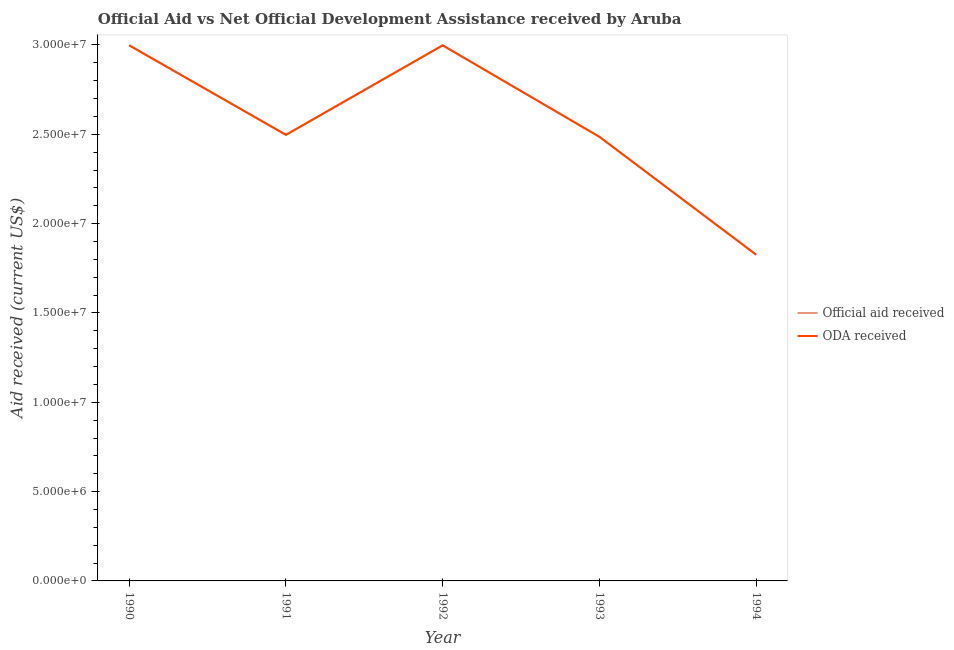What is the oda received in 1993?
Your response must be concise. 2.49e+07. Across all years, what is the maximum oda received?
Offer a very short reply. 3.00e+07. Across all years, what is the minimum official aid received?
Ensure brevity in your answer.  1.83e+07. In which year was the oda received maximum?
Provide a succinct answer. 1990. What is the total official aid received in the graph?
Your response must be concise. 1.28e+08. What is the difference between the oda received in 1991 and that in 1994?
Ensure brevity in your answer.  6.71e+06. What is the difference between the official aid received in 1991 and the oda received in 1993?
Offer a terse response. 1.10e+05. What is the average oda received per year?
Offer a terse response. 2.56e+07. In the year 1993, what is the difference between the official aid received and oda received?
Offer a terse response. 0. What is the ratio of the oda received in 1990 to that in 1991?
Provide a succinct answer. 1.2. Is the oda received in 1991 less than that in 1994?
Your response must be concise. No. Is the difference between the oda received in 1991 and 1992 greater than the difference between the official aid received in 1991 and 1992?
Your response must be concise. No. What is the difference between the highest and the second highest oda received?
Offer a terse response. 0. What is the difference between the highest and the lowest oda received?
Your answer should be compact. 1.17e+07. In how many years, is the oda received greater than the average oda received taken over all years?
Your answer should be very brief. 2. Is the sum of the official aid received in 1991 and 1993 greater than the maximum oda received across all years?
Your response must be concise. Yes. Does the oda received monotonically increase over the years?
Your answer should be compact. No. How many lines are there?
Give a very brief answer. 2. Does the graph contain grids?
Keep it short and to the point. No. Where does the legend appear in the graph?
Your answer should be very brief. Center right. How are the legend labels stacked?
Your answer should be very brief. Vertical. What is the title of the graph?
Make the answer very short. Official Aid vs Net Official Development Assistance received by Aruba . Does "Birth rate" appear as one of the legend labels in the graph?
Provide a short and direct response. No. What is the label or title of the X-axis?
Offer a very short reply. Year. What is the label or title of the Y-axis?
Provide a short and direct response. Aid received (current US$). What is the Aid received (current US$) in Official aid received in 1990?
Ensure brevity in your answer.  3.00e+07. What is the Aid received (current US$) in ODA received in 1990?
Your response must be concise. 3.00e+07. What is the Aid received (current US$) in Official aid received in 1991?
Offer a very short reply. 2.50e+07. What is the Aid received (current US$) of ODA received in 1991?
Ensure brevity in your answer.  2.50e+07. What is the Aid received (current US$) in Official aid received in 1992?
Provide a succinct answer. 3.00e+07. What is the Aid received (current US$) of ODA received in 1992?
Your answer should be very brief. 3.00e+07. What is the Aid received (current US$) of Official aid received in 1993?
Provide a succinct answer. 2.49e+07. What is the Aid received (current US$) in ODA received in 1993?
Offer a terse response. 2.49e+07. What is the Aid received (current US$) in Official aid received in 1994?
Offer a very short reply. 1.83e+07. What is the Aid received (current US$) of ODA received in 1994?
Offer a terse response. 1.83e+07. Across all years, what is the maximum Aid received (current US$) in Official aid received?
Offer a very short reply. 3.00e+07. Across all years, what is the maximum Aid received (current US$) in ODA received?
Offer a terse response. 3.00e+07. Across all years, what is the minimum Aid received (current US$) in Official aid received?
Your response must be concise. 1.83e+07. Across all years, what is the minimum Aid received (current US$) in ODA received?
Your answer should be compact. 1.83e+07. What is the total Aid received (current US$) of Official aid received in the graph?
Your answer should be very brief. 1.28e+08. What is the total Aid received (current US$) of ODA received in the graph?
Your response must be concise. 1.28e+08. What is the difference between the Aid received (current US$) in Official aid received in 1990 and that in 1991?
Offer a very short reply. 5.01e+06. What is the difference between the Aid received (current US$) in ODA received in 1990 and that in 1991?
Give a very brief answer. 5.01e+06. What is the difference between the Aid received (current US$) of Official aid received in 1990 and that in 1992?
Give a very brief answer. 0. What is the difference between the Aid received (current US$) in Official aid received in 1990 and that in 1993?
Your response must be concise. 5.12e+06. What is the difference between the Aid received (current US$) in ODA received in 1990 and that in 1993?
Provide a succinct answer. 5.12e+06. What is the difference between the Aid received (current US$) in Official aid received in 1990 and that in 1994?
Your answer should be compact. 1.17e+07. What is the difference between the Aid received (current US$) of ODA received in 1990 and that in 1994?
Keep it short and to the point. 1.17e+07. What is the difference between the Aid received (current US$) of Official aid received in 1991 and that in 1992?
Make the answer very short. -5.01e+06. What is the difference between the Aid received (current US$) of ODA received in 1991 and that in 1992?
Your answer should be very brief. -5.01e+06. What is the difference between the Aid received (current US$) of ODA received in 1991 and that in 1993?
Provide a succinct answer. 1.10e+05. What is the difference between the Aid received (current US$) in Official aid received in 1991 and that in 1994?
Offer a very short reply. 6.71e+06. What is the difference between the Aid received (current US$) of ODA received in 1991 and that in 1994?
Your answer should be very brief. 6.71e+06. What is the difference between the Aid received (current US$) of Official aid received in 1992 and that in 1993?
Give a very brief answer. 5.12e+06. What is the difference between the Aid received (current US$) in ODA received in 1992 and that in 1993?
Ensure brevity in your answer.  5.12e+06. What is the difference between the Aid received (current US$) in Official aid received in 1992 and that in 1994?
Give a very brief answer. 1.17e+07. What is the difference between the Aid received (current US$) in ODA received in 1992 and that in 1994?
Your response must be concise. 1.17e+07. What is the difference between the Aid received (current US$) of Official aid received in 1993 and that in 1994?
Ensure brevity in your answer.  6.60e+06. What is the difference between the Aid received (current US$) of ODA received in 1993 and that in 1994?
Ensure brevity in your answer.  6.60e+06. What is the difference between the Aid received (current US$) of Official aid received in 1990 and the Aid received (current US$) of ODA received in 1991?
Keep it short and to the point. 5.01e+06. What is the difference between the Aid received (current US$) in Official aid received in 1990 and the Aid received (current US$) in ODA received in 1992?
Offer a very short reply. 0. What is the difference between the Aid received (current US$) in Official aid received in 1990 and the Aid received (current US$) in ODA received in 1993?
Give a very brief answer. 5.12e+06. What is the difference between the Aid received (current US$) of Official aid received in 1990 and the Aid received (current US$) of ODA received in 1994?
Give a very brief answer. 1.17e+07. What is the difference between the Aid received (current US$) of Official aid received in 1991 and the Aid received (current US$) of ODA received in 1992?
Offer a very short reply. -5.01e+06. What is the difference between the Aid received (current US$) of Official aid received in 1991 and the Aid received (current US$) of ODA received in 1993?
Provide a succinct answer. 1.10e+05. What is the difference between the Aid received (current US$) of Official aid received in 1991 and the Aid received (current US$) of ODA received in 1994?
Ensure brevity in your answer.  6.71e+06. What is the difference between the Aid received (current US$) of Official aid received in 1992 and the Aid received (current US$) of ODA received in 1993?
Provide a succinct answer. 5.12e+06. What is the difference between the Aid received (current US$) of Official aid received in 1992 and the Aid received (current US$) of ODA received in 1994?
Keep it short and to the point. 1.17e+07. What is the difference between the Aid received (current US$) of Official aid received in 1993 and the Aid received (current US$) of ODA received in 1994?
Keep it short and to the point. 6.60e+06. What is the average Aid received (current US$) in Official aid received per year?
Give a very brief answer. 2.56e+07. What is the average Aid received (current US$) of ODA received per year?
Your answer should be very brief. 2.56e+07. In the year 1990, what is the difference between the Aid received (current US$) in Official aid received and Aid received (current US$) in ODA received?
Your answer should be very brief. 0. In the year 1992, what is the difference between the Aid received (current US$) of Official aid received and Aid received (current US$) of ODA received?
Offer a terse response. 0. In the year 1993, what is the difference between the Aid received (current US$) in Official aid received and Aid received (current US$) in ODA received?
Your answer should be compact. 0. What is the ratio of the Aid received (current US$) of Official aid received in 1990 to that in 1991?
Make the answer very short. 1.2. What is the ratio of the Aid received (current US$) of ODA received in 1990 to that in 1991?
Ensure brevity in your answer.  1.2. What is the ratio of the Aid received (current US$) in Official aid received in 1990 to that in 1993?
Give a very brief answer. 1.21. What is the ratio of the Aid received (current US$) of ODA received in 1990 to that in 1993?
Your answer should be very brief. 1.21. What is the ratio of the Aid received (current US$) in Official aid received in 1990 to that in 1994?
Your answer should be compact. 1.64. What is the ratio of the Aid received (current US$) of ODA received in 1990 to that in 1994?
Provide a short and direct response. 1.64. What is the ratio of the Aid received (current US$) in Official aid received in 1991 to that in 1992?
Your answer should be very brief. 0.83. What is the ratio of the Aid received (current US$) in ODA received in 1991 to that in 1992?
Ensure brevity in your answer.  0.83. What is the ratio of the Aid received (current US$) of ODA received in 1991 to that in 1993?
Ensure brevity in your answer.  1. What is the ratio of the Aid received (current US$) of Official aid received in 1991 to that in 1994?
Keep it short and to the point. 1.37. What is the ratio of the Aid received (current US$) in ODA received in 1991 to that in 1994?
Your response must be concise. 1.37. What is the ratio of the Aid received (current US$) in Official aid received in 1992 to that in 1993?
Your response must be concise. 1.21. What is the ratio of the Aid received (current US$) of ODA received in 1992 to that in 1993?
Offer a terse response. 1.21. What is the ratio of the Aid received (current US$) in Official aid received in 1992 to that in 1994?
Offer a terse response. 1.64. What is the ratio of the Aid received (current US$) of ODA received in 1992 to that in 1994?
Your answer should be compact. 1.64. What is the ratio of the Aid received (current US$) of Official aid received in 1993 to that in 1994?
Offer a very short reply. 1.36. What is the ratio of the Aid received (current US$) in ODA received in 1993 to that in 1994?
Your answer should be very brief. 1.36. What is the difference between the highest and the second highest Aid received (current US$) of ODA received?
Your response must be concise. 0. What is the difference between the highest and the lowest Aid received (current US$) in Official aid received?
Offer a very short reply. 1.17e+07. What is the difference between the highest and the lowest Aid received (current US$) of ODA received?
Offer a very short reply. 1.17e+07. 